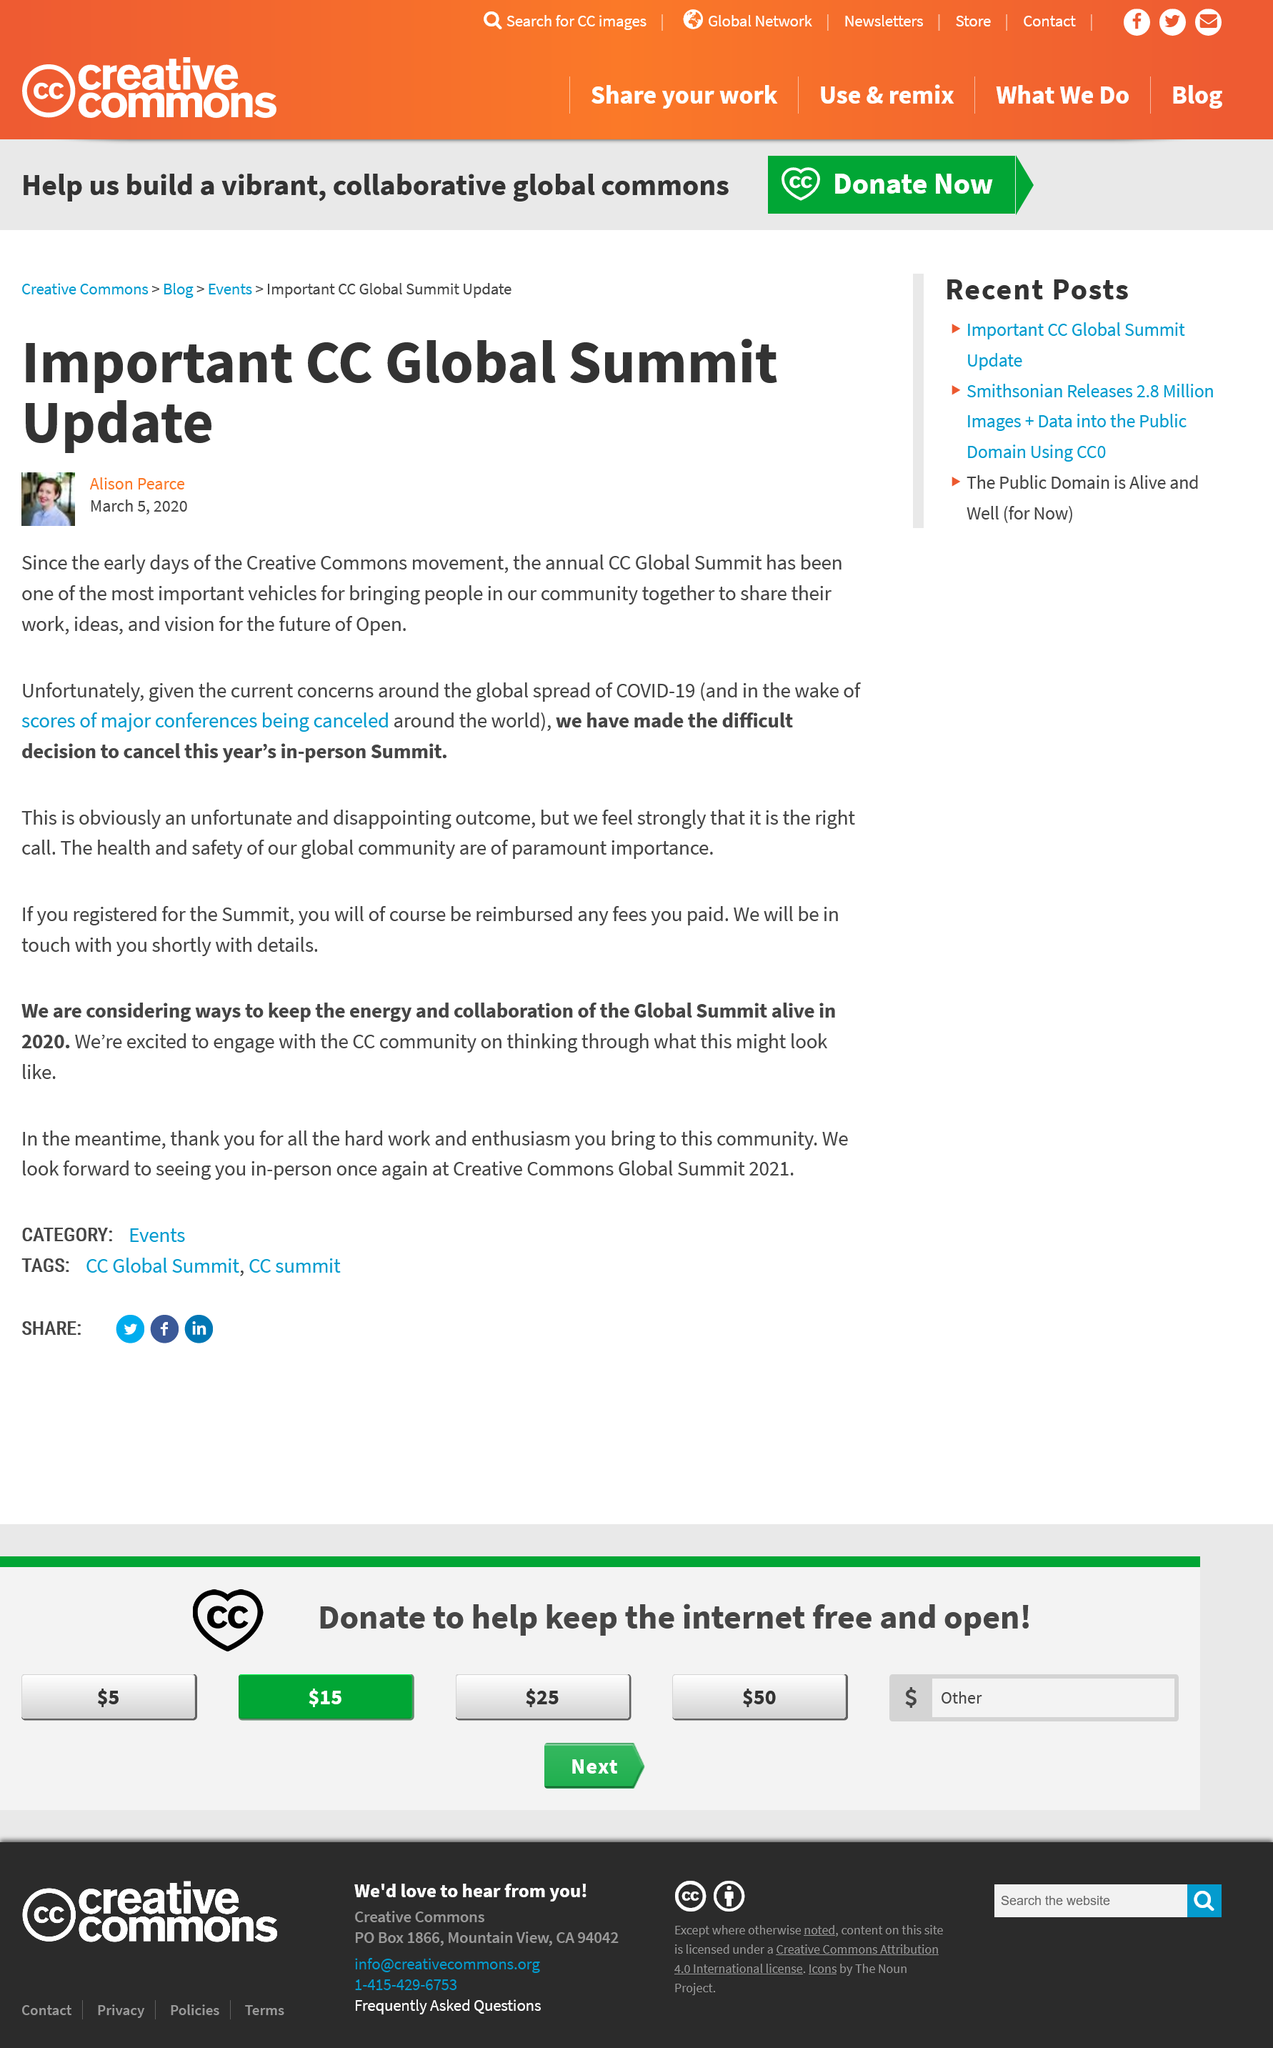Draw attention to some important aspects in this diagram. The CC Global Summit was cancelled in 2020 due to the COVID-19 pandemic. On March 5, 2020, a significant update regarding the CC Global Summit was announced. This update concerned the cancellation of the in-person Summit, which was scheduled to take place later that year. The 2020 CC Global in-person Summit was cancelled due to the COVID-19 pandemic. 